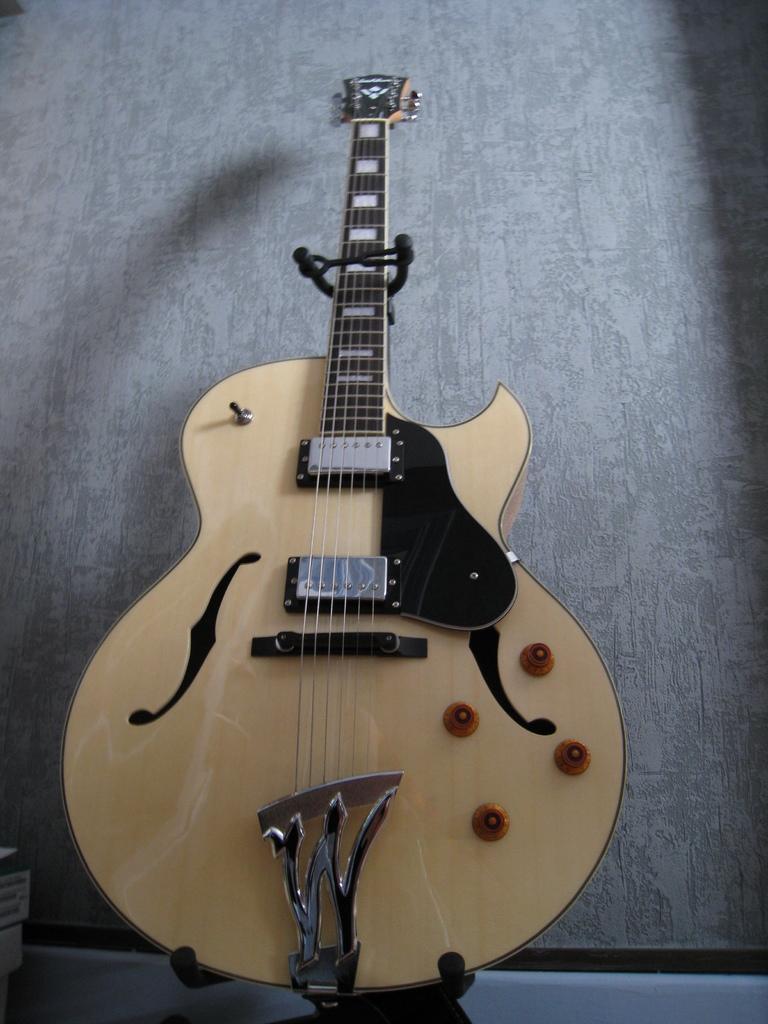How would you summarize this image in a sentence or two? In this image there is a guitar. It has six strings and four knobs. 